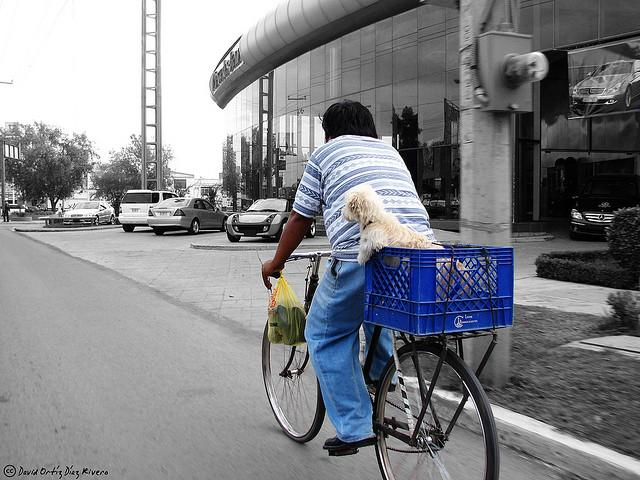Why is there a car poster on the building? dealership 